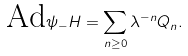Convert formula to latex. <formula><loc_0><loc_0><loc_500><loc_500>\text {Ad} \psi _ { - } H = \sum _ { n \geq 0 } \lambda ^ { - n } Q _ { n } .</formula> 